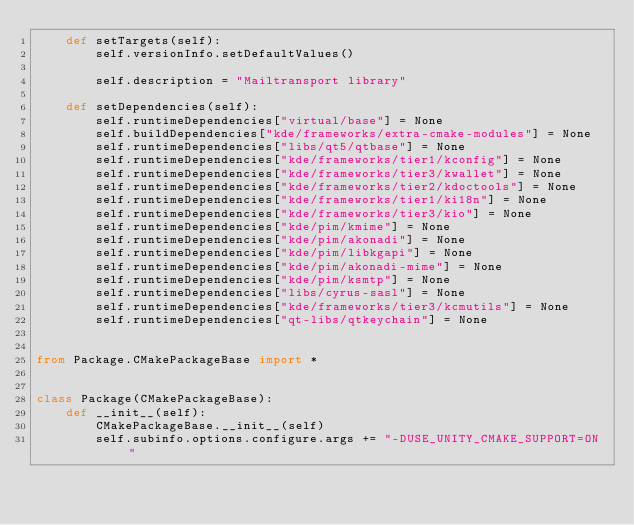Convert code to text. <code><loc_0><loc_0><loc_500><loc_500><_Python_>    def setTargets(self):
        self.versionInfo.setDefaultValues()

        self.description = "Mailtransport library"

    def setDependencies(self):
        self.runtimeDependencies["virtual/base"] = None
        self.buildDependencies["kde/frameworks/extra-cmake-modules"] = None
        self.runtimeDependencies["libs/qt5/qtbase"] = None
        self.runtimeDependencies["kde/frameworks/tier1/kconfig"] = None
        self.runtimeDependencies["kde/frameworks/tier3/kwallet"] = None
        self.runtimeDependencies["kde/frameworks/tier2/kdoctools"] = None
        self.runtimeDependencies["kde/frameworks/tier1/ki18n"] = None
        self.runtimeDependencies["kde/frameworks/tier3/kio"] = None
        self.runtimeDependencies["kde/pim/kmime"] = None
        self.runtimeDependencies["kde/pim/akonadi"] = None
        self.runtimeDependencies["kde/pim/libkgapi"] = None
        self.runtimeDependencies["kde/pim/akonadi-mime"] = None
        self.runtimeDependencies["kde/pim/ksmtp"] = None
        self.runtimeDependencies["libs/cyrus-sasl"] = None
        self.runtimeDependencies["kde/frameworks/tier3/kcmutils"] = None
        self.runtimeDependencies["qt-libs/qtkeychain"] = None


from Package.CMakePackageBase import *


class Package(CMakePackageBase):
    def __init__(self):
        CMakePackageBase.__init__(self)
        self.subinfo.options.configure.args += "-DUSE_UNITY_CMAKE_SUPPORT=ON "
</code> 